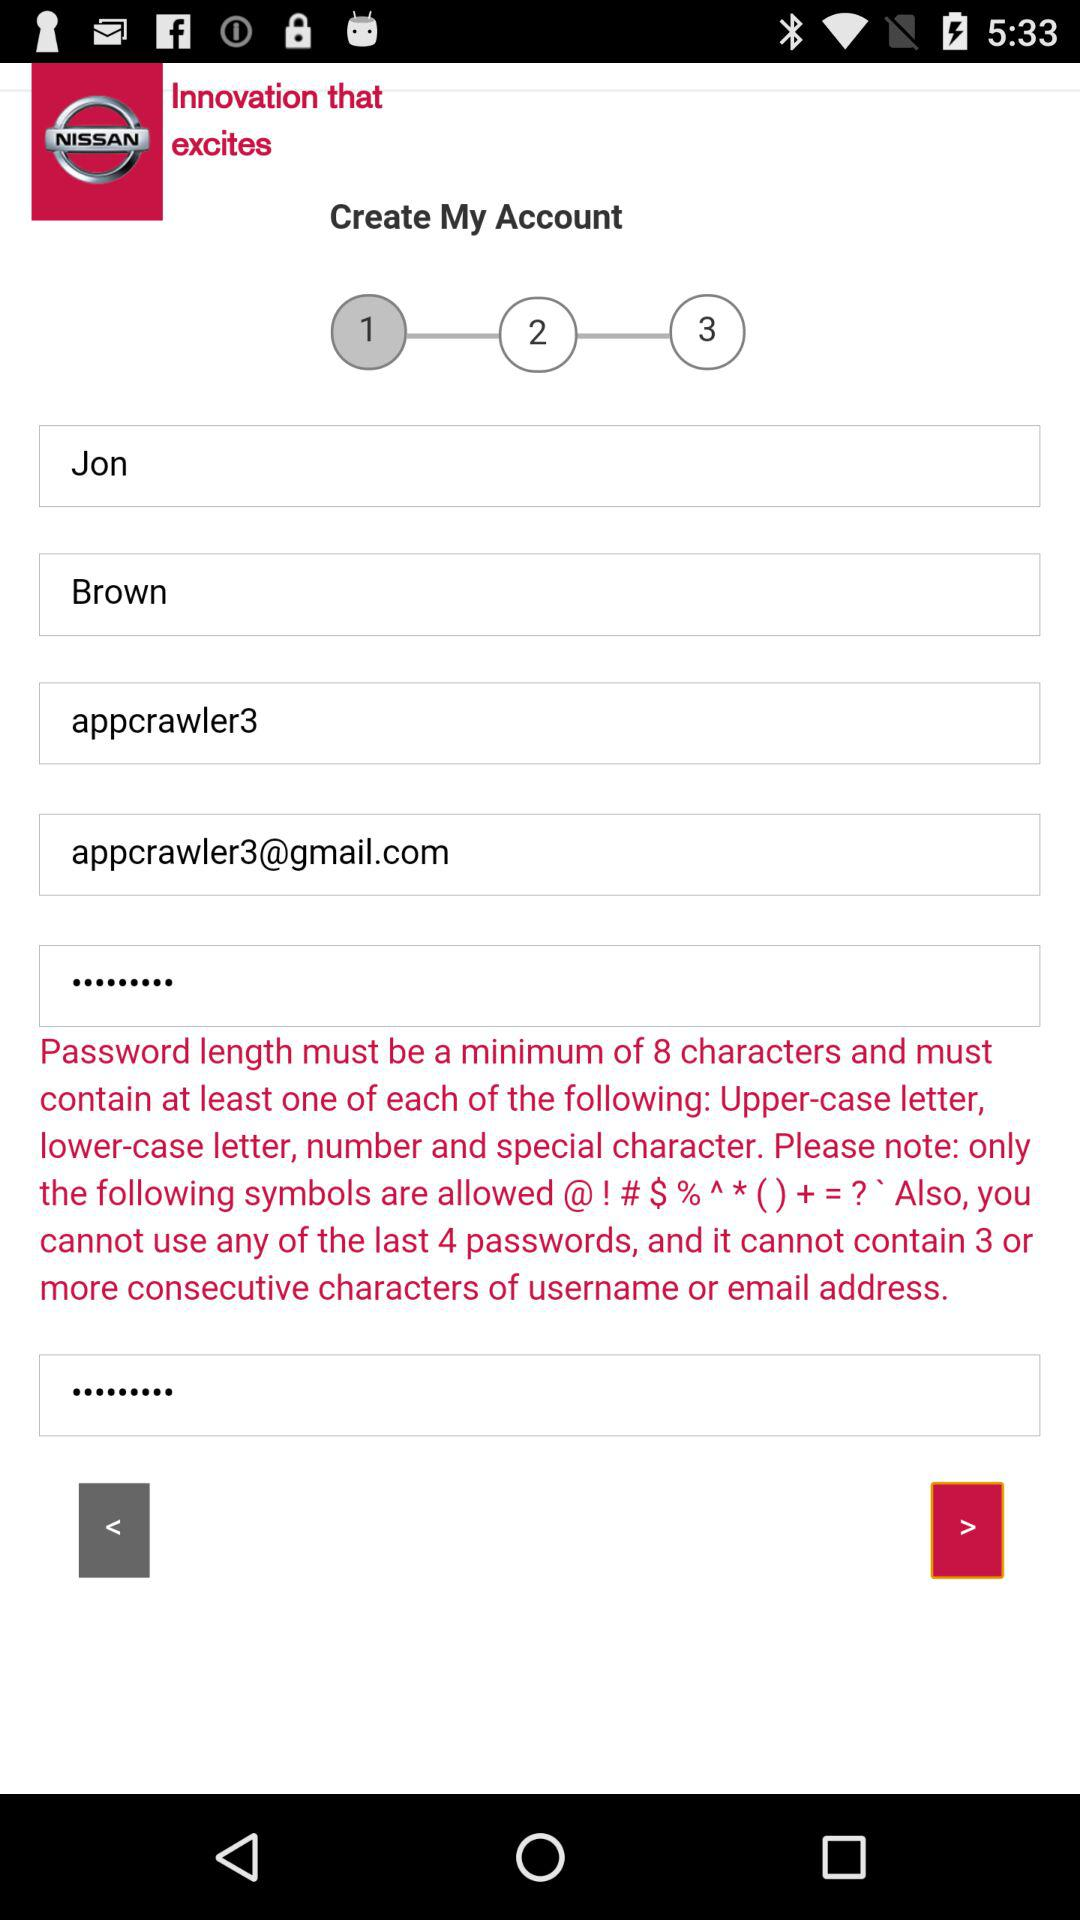What is the email address? The email address is appcrawler3@gmail.com. 